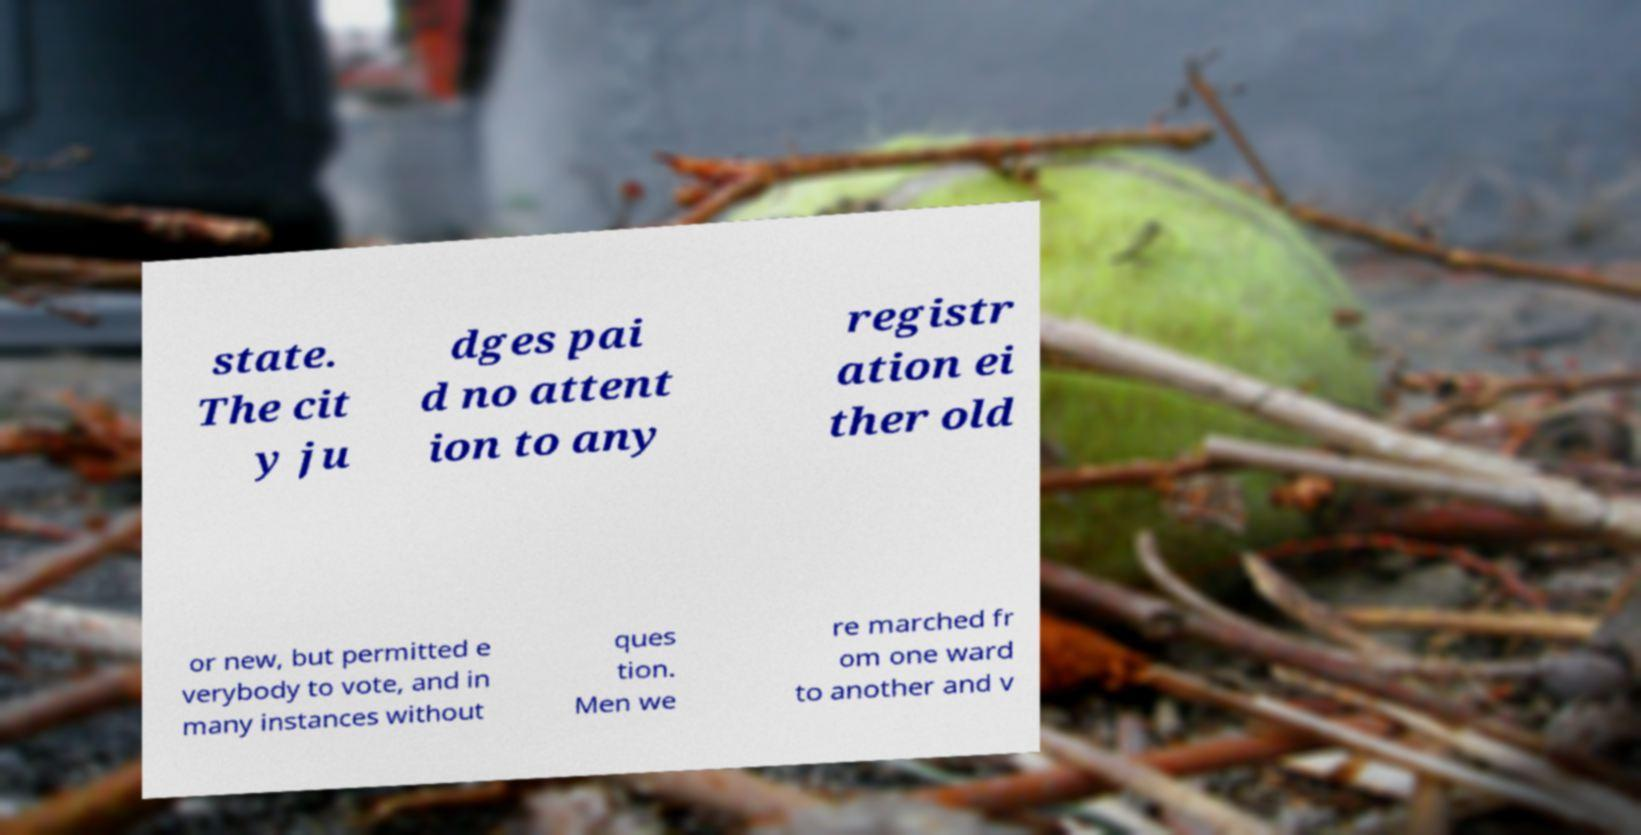Can you read and provide the text displayed in the image?This photo seems to have some interesting text. Can you extract and type it out for me? state. The cit y ju dges pai d no attent ion to any registr ation ei ther old or new, but permitted e verybody to vote, and in many instances without ques tion. Men we re marched fr om one ward to another and v 